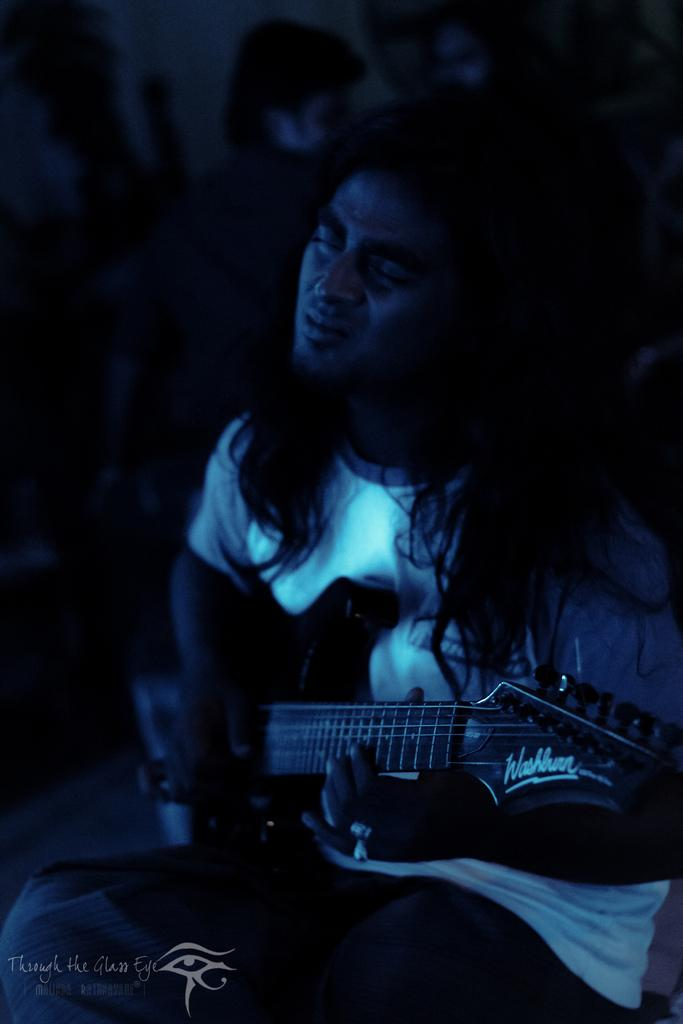Who is the main subject in the image? There is a man in the image. What is the man wearing? The man is wearing a white t-shirt. What is the man holding in the image? The man is holding a musical instrument. What is the man's facial expression or action in the image? The man has his eyes closed. What type of haircut does the man have in the image? The provided facts do not mention the man's haircut, so we cannot determine his haircut from the image. 